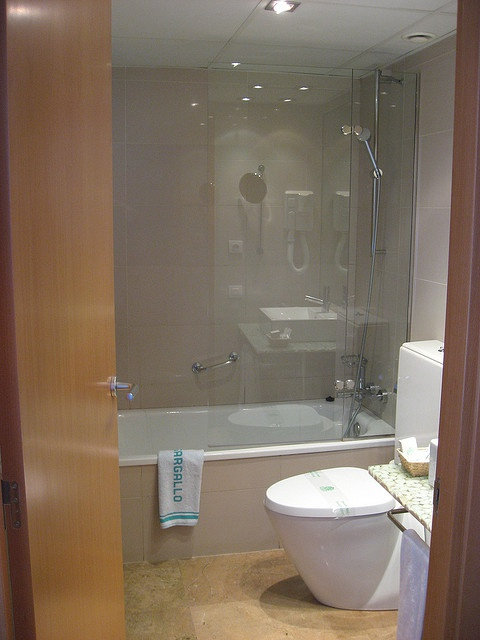Describe the objects in this image and their specific colors. I can see toilet in black, darkgray, lightgray, and gray tones and sink in black and gray tones in this image. 